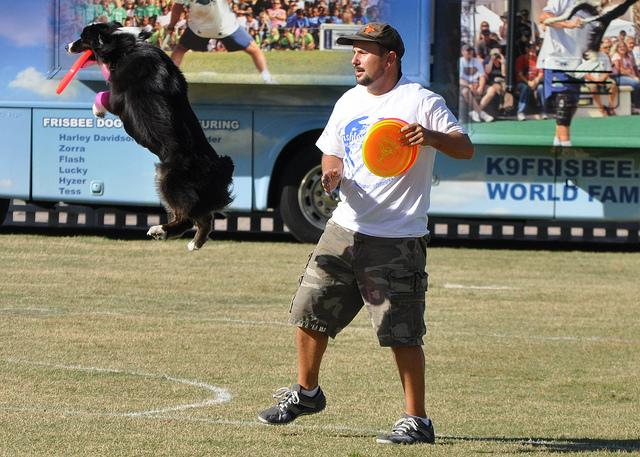Why did the dog jump in the air? catch frisbee 